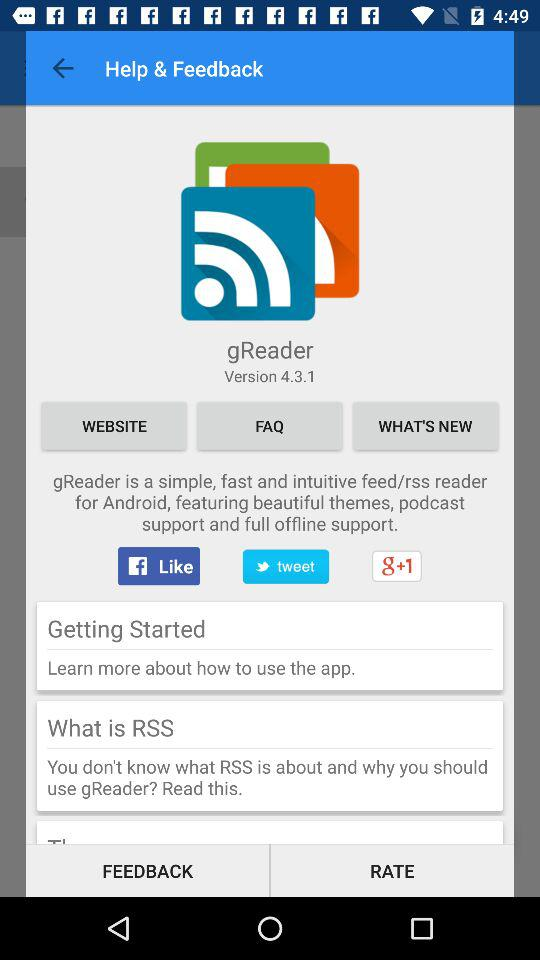What is the application name? The application name is "gReader". 